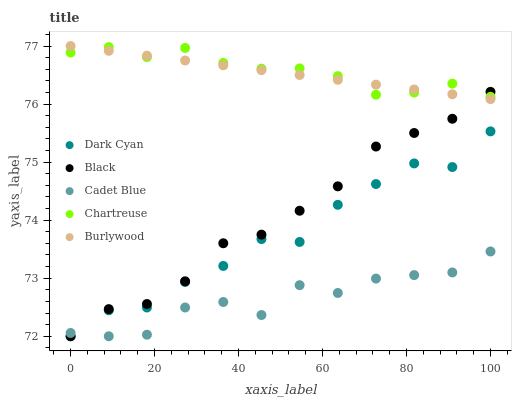Does Cadet Blue have the minimum area under the curve?
Answer yes or no. Yes. Does Chartreuse have the maximum area under the curve?
Answer yes or no. Yes. Does Burlywood have the minimum area under the curve?
Answer yes or no. No. Does Burlywood have the maximum area under the curve?
Answer yes or no. No. Is Burlywood the smoothest?
Answer yes or no. Yes. Is Dark Cyan the roughest?
Answer yes or no. Yes. Is Chartreuse the smoothest?
Answer yes or no. No. Is Chartreuse the roughest?
Answer yes or no. No. Does Dark Cyan have the lowest value?
Answer yes or no. Yes. Does Burlywood have the lowest value?
Answer yes or no. No. Does Burlywood have the highest value?
Answer yes or no. Yes. Does Chartreuse have the highest value?
Answer yes or no. No. Is Cadet Blue less than Chartreuse?
Answer yes or no. Yes. Is Chartreuse greater than Dark Cyan?
Answer yes or no. Yes. Does Black intersect Dark Cyan?
Answer yes or no. Yes. Is Black less than Dark Cyan?
Answer yes or no. No. Is Black greater than Dark Cyan?
Answer yes or no. No. Does Cadet Blue intersect Chartreuse?
Answer yes or no. No. 